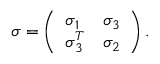Convert formula to latex. <formula><loc_0><loc_0><loc_500><loc_500>\sigma = \left ( \begin{array} { l l } { \sigma _ { 1 } } & { \sigma _ { 3 } } \\ { \sigma _ { 3 } ^ { T } } & { \sigma _ { 2 } } \end{array} \right ) .</formula> 